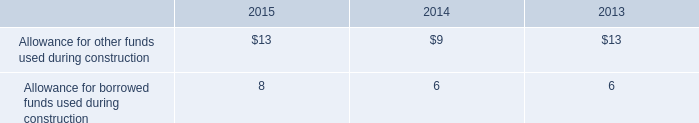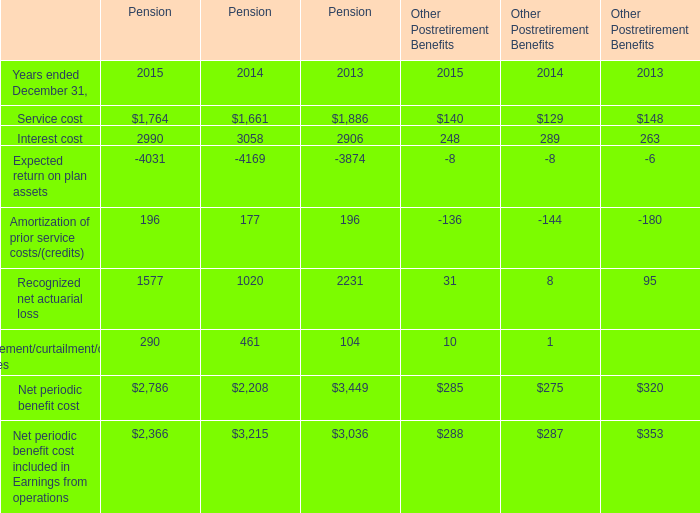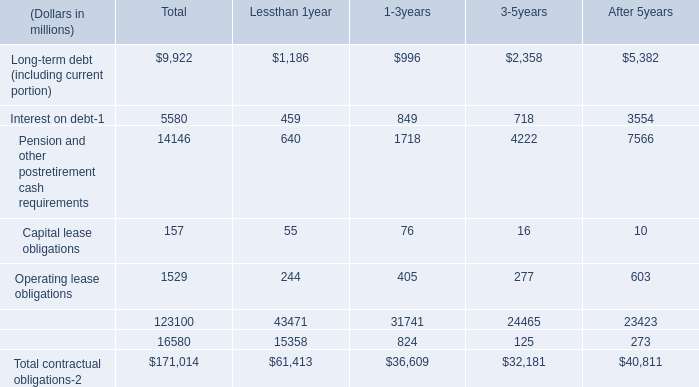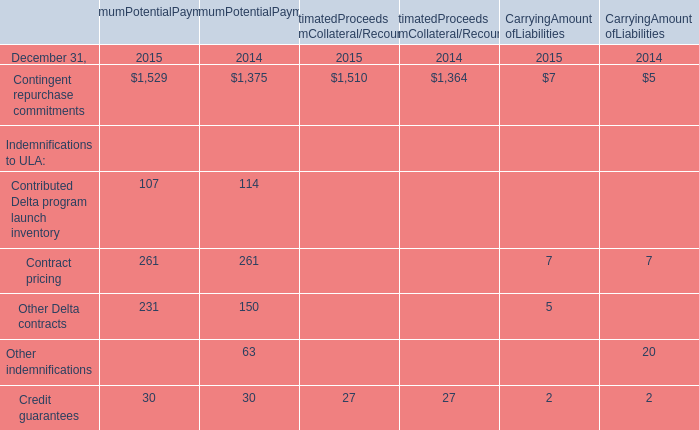what was the growth in allowance for other funds used during construction from 2013 to 2014 
Computations: ((9 - 13) / 9)
Answer: -0.44444. 